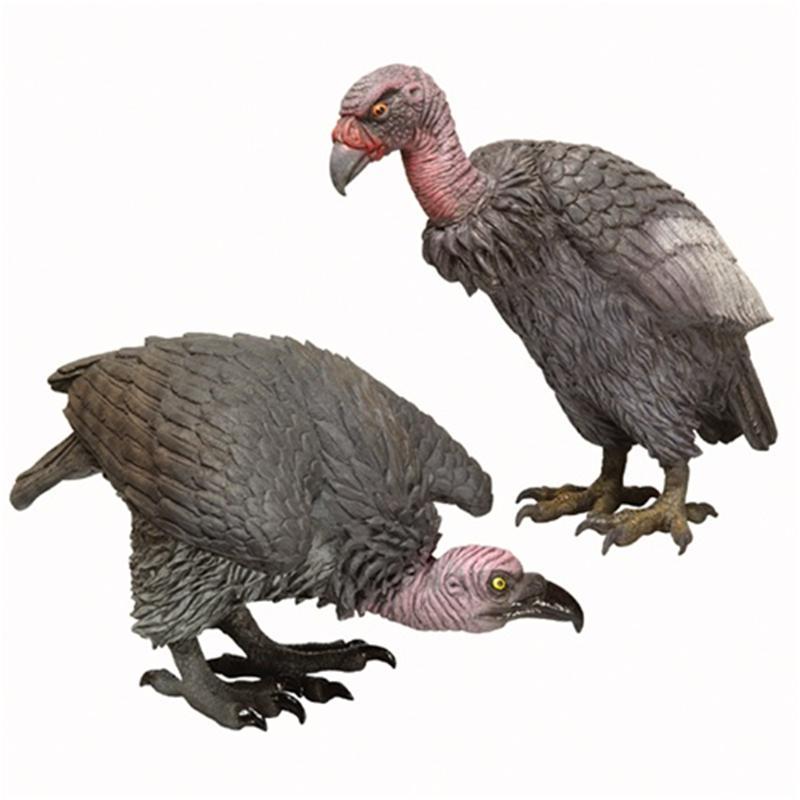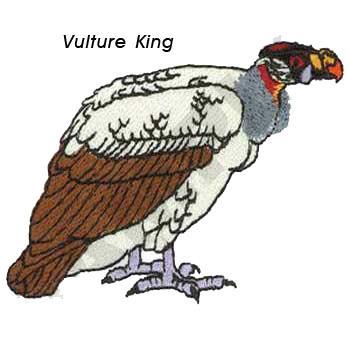The first image is the image on the left, the second image is the image on the right. Analyze the images presented: Is the assertion "There are 2 birds." valid? Answer yes or no. No. 